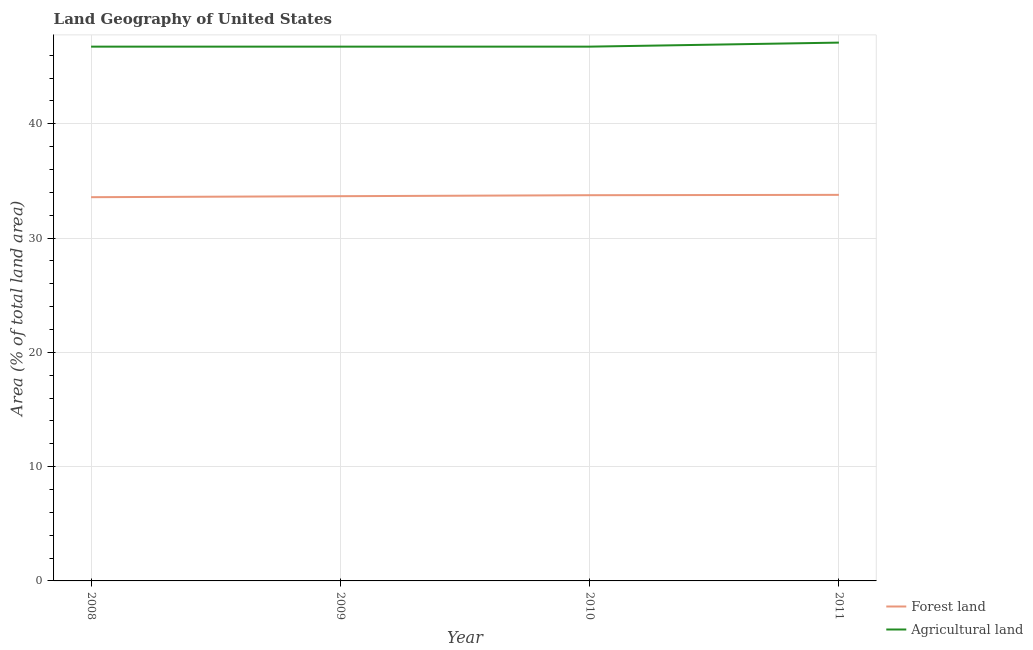What is the percentage of land area under forests in 2008?
Give a very brief answer. 33.58. Across all years, what is the maximum percentage of land area under forests?
Your answer should be very brief. 33.78. Across all years, what is the minimum percentage of land area under forests?
Your response must be concise. 33.58. In which year was the percentage of land area under forests maximum?
Your answer should be compact. 2011. What is the total percentage of land area under agriculture in the graph?
Offer a terse response. 187.35. What is the difference between the percentage of land area under forests in 2009 and that in 2011?
Your answer should be compact. -0.12. What is the difference between the percentage of land area under agriculture in 2008 and the percentage of land area under forests in 2011?
Your response must be concise. 12.97. What is the average percentage of land area under agriculture per year?
Offer a very short reply. 46.84. In the year 2011, what is the difference between the percentage of land area under agriculture and percentage of land area under forests?
Make the answer very short. 13.32. In how many years, is the percentage of land area under forests greater than 20 %?
Give a very brief answer. 4. What is the ratio of the percentage of land area under agriculture in 2010 to that in 2011?
Give a very brief answer. 0.99. Is the percentage of land area under forests in 2008 less than that in 2010?
Give a very brief answer. Yes. Is the difference between the percentage of land area under forests in 2008 and 2009 greater than the difference between the percentage of land area under agriculture in 2008 and 2009?
Your answer should be compact. No. What is the difference between the highest and the second highest percentage of land area under forests?
Offer a very short reply. 0.03. What is the difference between the highest and the lowest percentage of land area under agriculture?
Provide a short and direct response. 0.35. How many years are there in the graph?
Offer a very short reply. 4. Does the graph contain any zero values?
Offer a terse response. No. How many legend labels are there?
Your answer should be very brief. 2. How are the legend labels stacked?
Your response must be concise. Vertical. What is the title of the graph?
Offer a terse response. Land Geography of United States. What is the label or title of the X-axis?
Offer a terse response. Year. What is the label or title of the Y-axis?
Provide a short and direct response. Area (% of total land area). What is the Area (% of total land area) in Forest land in 2008?
Your answer should be compact. 33.58. What is the Area (% of total land area) of Agricultural land in 2008?
Your response must be concise. 46.75. What is the Area (% of total land area) in Forest land in 2009?
Your response must be concise. 33.66. What is the Area (% of total land area) of Agricultural land in 2009?
Offer a very short reply. 46.75. What is the Area (% of total land area) in Forest land in 2010?
Offer a very short reply. 33.75. What is the Area (% of total land area) of Agricultural land in 2010?
Provide a succinct answer. 46.75. What is the Area (% of total land area) of Forest land in 2011?
Keep it short and to the point. 33.78. What is the Area (% of total land area) of Agricultural land in 2011?
Your answer should be very brief. 47.1. Across all years, what is the maximum Area (% of total land area) in Forest land?
Ensure brevity in your answer.  33.78. Across all years, what is the maximum Area (% of total land area) in Agricultural land?
Your answer should be compact. 47.1. Across all years, what is the minimum Area (% of total land area) of Forest land?
Ensure brevity in your answer.  33.58. Across all years, what is the minimum Area (% of total land area) in Agricultural land?
Offer a very short reply. 46.75. What is the total Area (% of total land area) of Forest land in the graph?
Keep it short and to the point. 134.77. What is the total Area (% of total land area) of Agricultural land in the graph?
Your answer should be compact. 187.35. What is the difference between the Area (% of total land area) in Forest land in 2008 and that in 2009?
Offer a very short reply. -0.09. What is the difference between the Area (% of total land area) of Agricultural land in 2008 and that in 2009?
Your answer should be compact. 0. What is the difference between the Area (% of total land area) of Forest land in 2008 and that in 2010?
Provide a succinct answer. -0.17. What is the difference between the Area (% of total land area) of Agricultural land in 2008 and that in 2010?
Make the answer very short. 0. What is the difference between the Area (% of total land area) in Forest land in 2008 and that in 2011?
Your answer should be compact. -0.2. What is the difference between the Area (% of total land area) of Agricultural land in 2008 and that in 2011?
Ensure brevity in your answer.  -0.35. What is the difference between the Area (% of total land area) in Forest land in 2009 and that in 2010?
Ensure brevity in your answer.  -0.09. What is the difference between the Area (% of total land area) of Agricultural land in 2009 and that in 2010?
Give a very brief answer. 0. What is the difference between the Area (% of total land area) of Forest land in 2009 and that in 2011?
Provide a short and direct response. -0.12. What is the difference between the Area (% of total land area) of Agricultural land in 2009 and that in 2011?
Your answer should be very brief. -0.35. What is the difference between the Area (% of total land area) of Forest land in 2010 and that in 2011?
Keep it short and to the point. -0.03. What is the difference between the Area (% of total land area) of Agricultural land in 2010 and that in 2011?
Provide a short and direct response. -0.35. What is the difference between the Area (% of total land area) in Forest land in 2008 and the Area (% of total land area) in Agricultural land in 2009?
Your answer should be compact. -13.17. What is the difference between the Area (% of total land area) in Forest land in 2008 and the Area (% of total land area) in Agricultural land in 2010?
Offer a terse response. -13.17. What is the difference between the Area (% of total land area) in Forest land in 2008 and the Area (% of total land area) in Agricultural land in 2011?
Offer a very short reply. -13.53. What is the difference between the Area (% of total land area) in Forest land in 2009 and the Area (% of total land area) in Agricultural land in 2010?
Give a very brief answer. -13.09. What is the difference between the Area (% of total land area) of Forest land in 2009 and the Area (% of total land area) of Agricultural land in 2011?
Your answer should be very brief. -13.44. What is the difference between the Area (% of total land area) of Forest land in 2010 and the Area (% of total land area) of Agricultural land in 2011?
Make the answer very short. -13.35. What is the average Area (% of total land area) in Forest land per year?
Your response must be concise. 33.69. What is the average Area (% of total land area) in Agricultural land per year?
Your answer should be compact. 46.84. In the year 2008, what is the difference between the Area (% of total land area) of Forest land and Area (% of total land area) of Agricultural land?
Provide a succinct answer. -13.17. In the year 2009, what is the difference between the Area (% of total land area) of Forest land and Area (% of total land area) of Agricultural land?
Keep it short and to the point. -13.09. In the year 2010, what is the difference between the Area (% of total land area) in Forest land and Area (% of total land area) in Agricultural land?
Your answer should be compact. -13. In the year 2011, what is the difference between the Area (% of total land area) of Forest land and Area (% of total land area) of Agricultural land?
Offer a very short reply. -13.32. What is the ratio of the Area (% of total land area) in Forest land in 2008 to that in 2010?
Ensure brevity in your answer.  0.99. What is the ratio of the Area (% of total land area) of Agricultural land in 2008 to that in 2010?
Ensure brevity in your answer.  1. What is the ratio of the Area (% of total land area) of Forest land in 2008 to that in 2011?
Your response must be concise. 0.99. What is the ratio of the Area (% of total land area) in Agricultural land in 2008 to that in 2011?
Provide a short and direct response. 0.99. What is the ratio of the Area (% of total land area) of Forest land in 2009 to that in 2010?
Make the answer very short. 1. What is the ratio of the Area (% of total land area) in Forest land in 2009 to that in 2011?
Offer a very short reply. 1. What is the ratio of the Area (% of total land area) in Agricultural land in 2009 to that in 2011?
Offer a terse response. 0.99. What is the ratio of the Area (% of total land area) of Agricultural land in 2010 to that in 2011?
Ensure brevity in your answer.  0.99. What is the difference between the highest and the second highest Area (% of total land area) in Forest land?
Keep it short and to the point. 0.03. What is the difference between the highest and the second highest Area (% of total land area) of Agricultural land?
Offer a terse response. 0.35. What is the difference between the highest and the lowest Area (% of total land area) in Forest land?
Provide a short and direct response. 0.2. What is the difference between the highest and the lowest Area (% of total land area) in Agricultural land?
Provide a short and direct response. 0.35. 